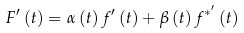Convert formula to latex. <formula><loc_0><loc_0><loc_500><loc_500>F ^ { \prime } \left ( t \right ) = \alpha \left ( t \right ) f ^ { \prime } \left ( t \right ) + \beta \left ( t \right ) f ^ { * ^ { \prime } } \left ( t \right )</formula> 